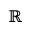<formula> <loc_0><loc_0><loc_500><loc_500>\mathbb { R }</formula> 